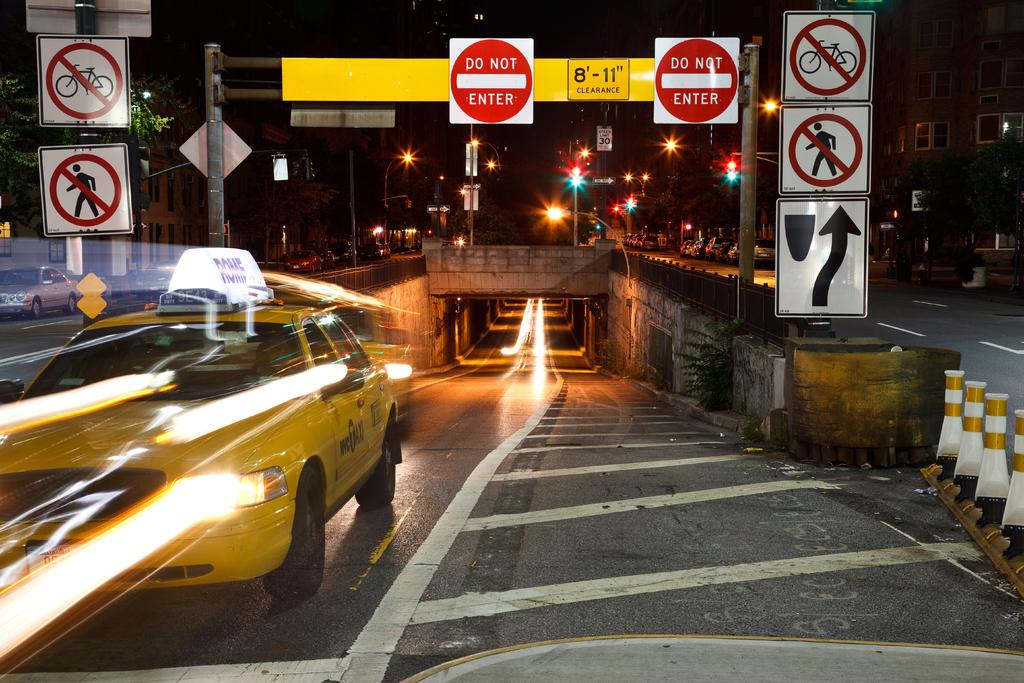<image>
Share a concise interpretation of the image provided. A taxi drives out of a tunnel underneath a sign that says Do Not Enter. 